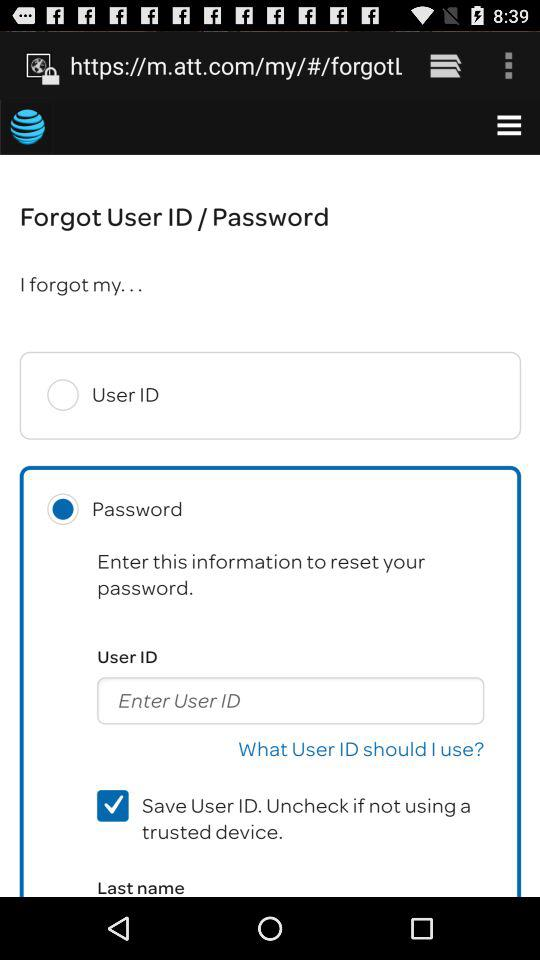Which is the selected radio button? The selected radio button is "Password". 